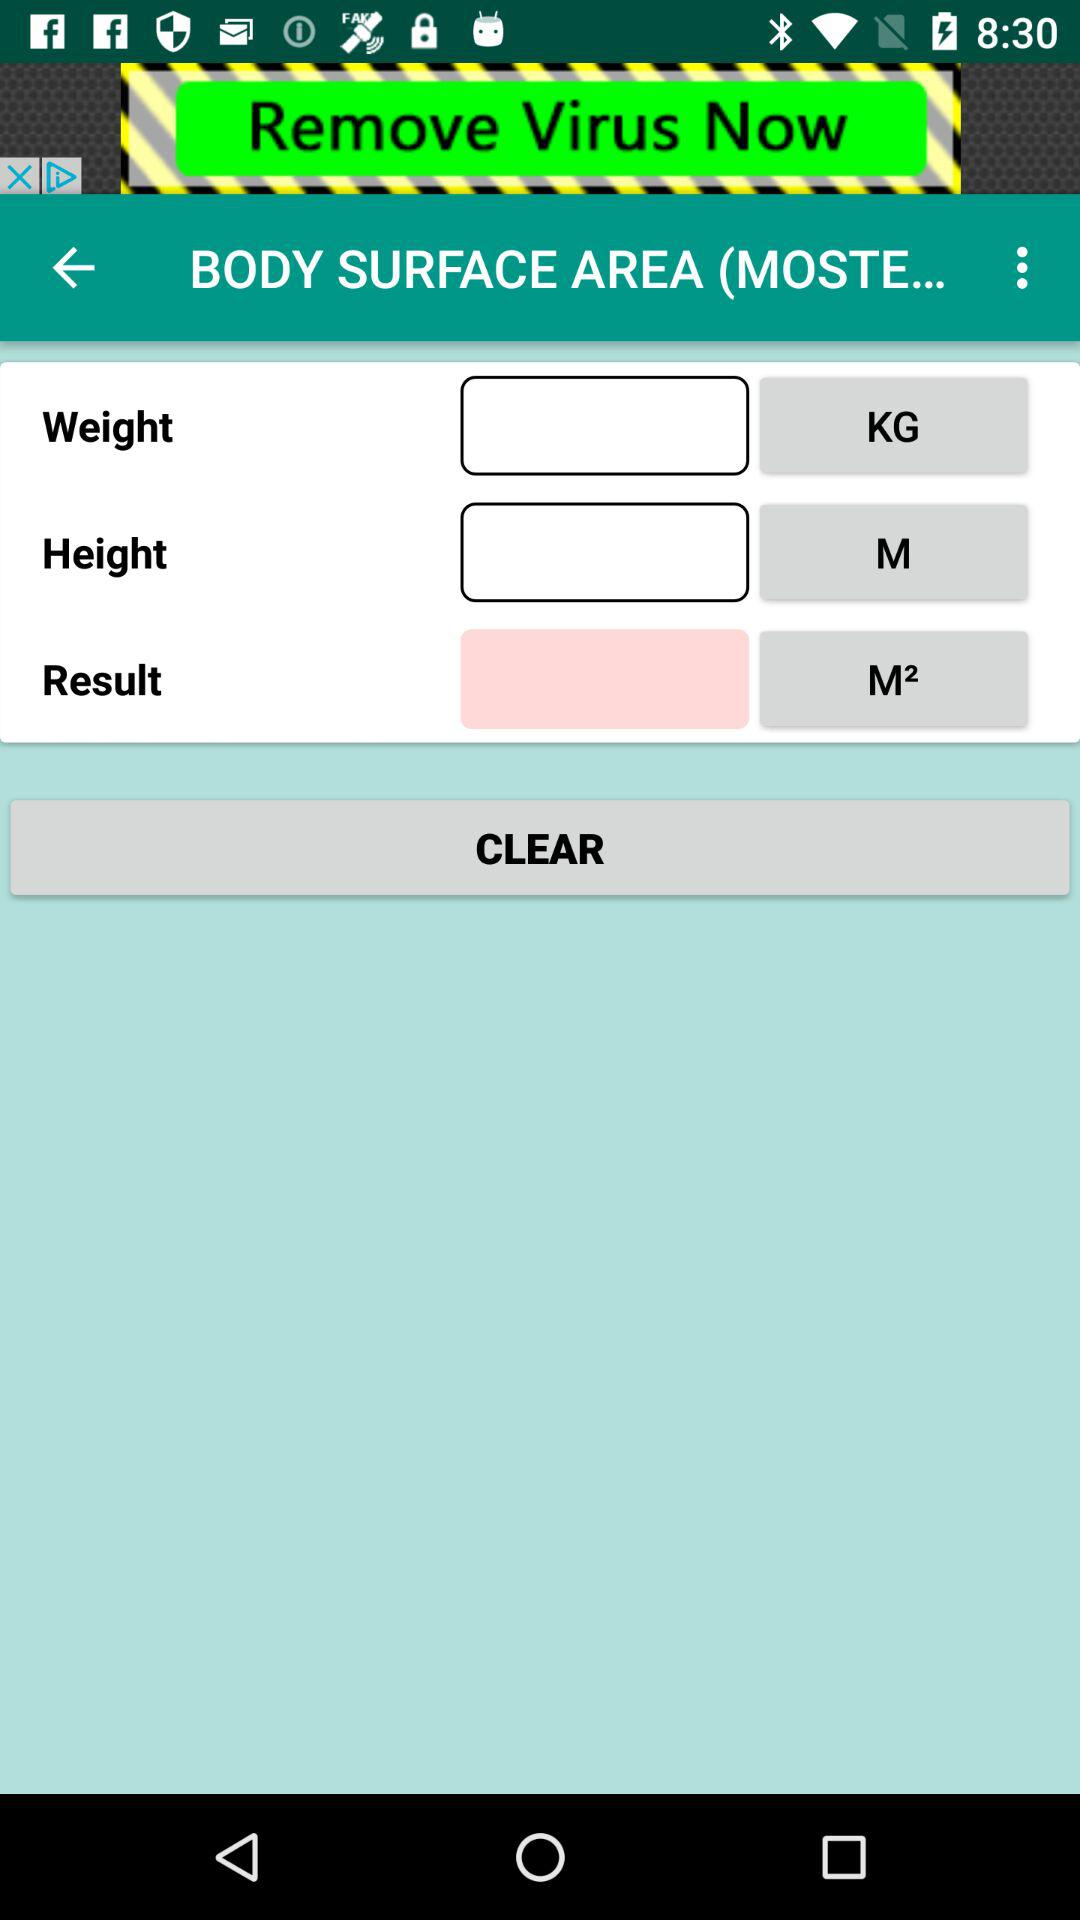What is the unit of height? The unit of height is "M". 